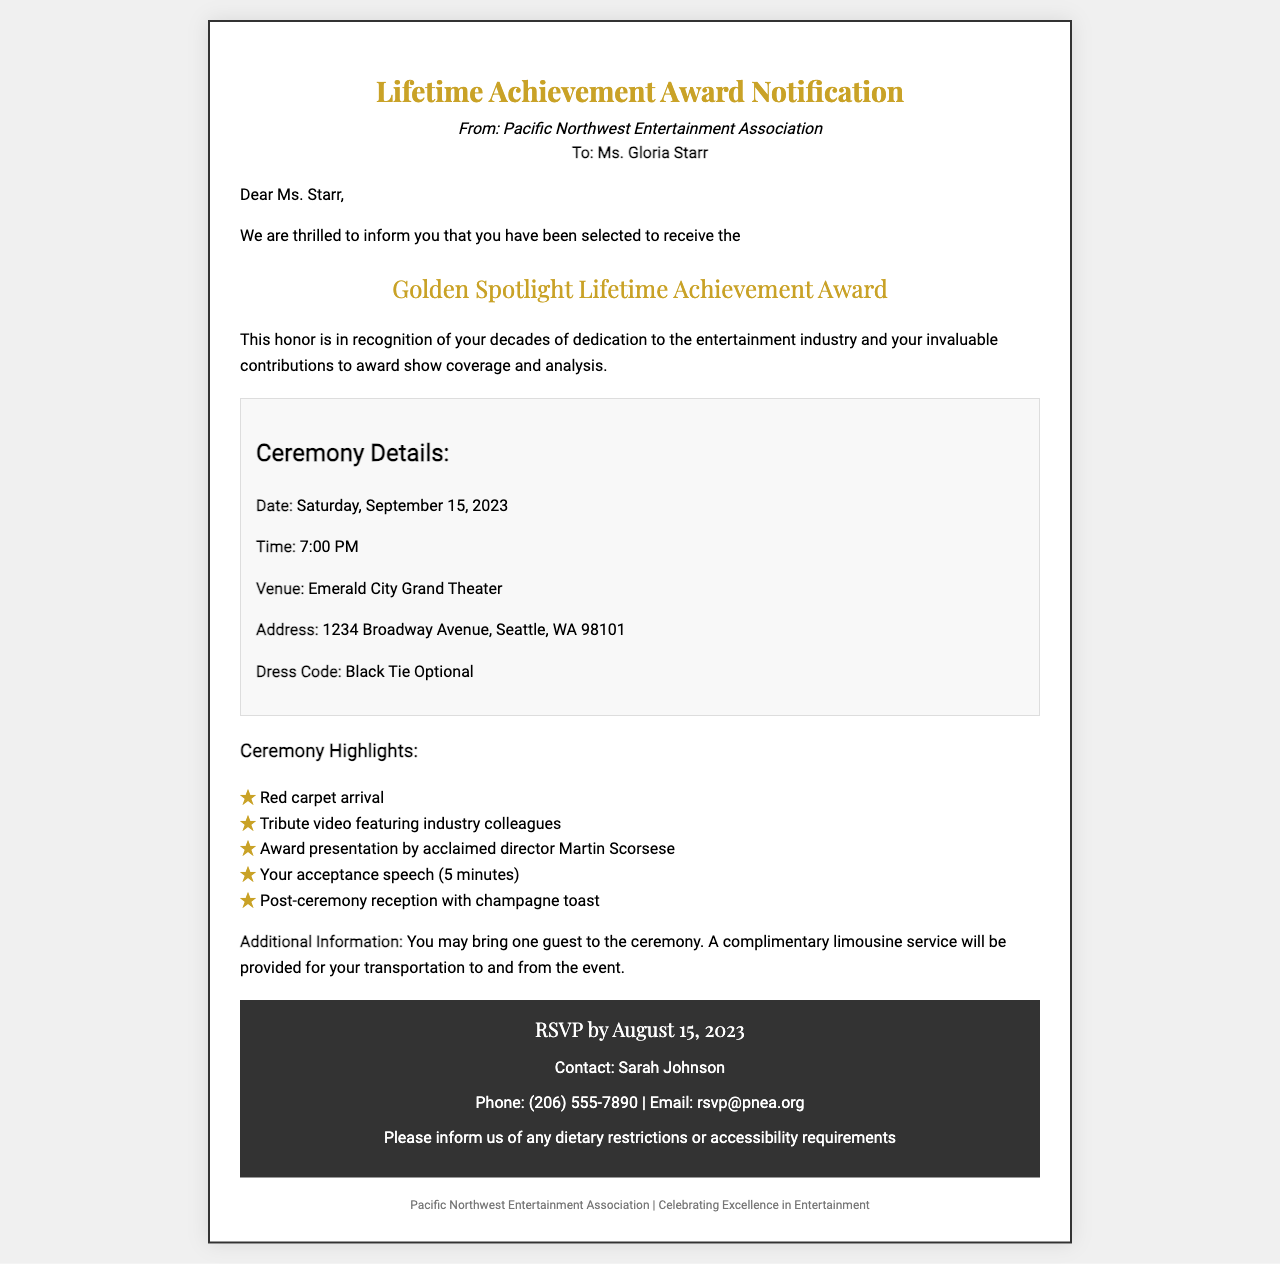What is the name of the award? The award being presented is specifically mentioned as the "Golden Spotlight Lifetime Achievement Award".
Answer: Golden Spotlight Lifetime Achievement Award Who is the award recipient? The document specifically addresses the award recipient as Ms. Gloria Starr.
Answer: Ms. Gloria Starr What is the ceremony date? The date of the ceremony is explicitly stated as Saturday, September 15, 2023.
Answer: September 15, 2023 What is the venue for the ceremony? The document highlights the venue for the event, which is the "Emerald City Grand Theater".
Answer: Emerald City Grand Theater Who will present the award? The award presentation is noted to be conducted by acclaimed director Martin Scorsese.
Answer: Martin Scorsese What time does the ceremony begin? The starting time for the ceremony is provided as 7:00 PM.
Answer: 7:00 PM When is the RSVP deadline? The document states that the RSVP must be completed by August 15, 2023.
Answer: August 15, 2023 What is the dress code? The document specifies the dress code as "Black Tie Optional".
Answer: Black Tie Optional What additional service is provided for guests? The document informs that complimentary limousine service will be provided for transportation to and from the event.
Answer: Limousine service 